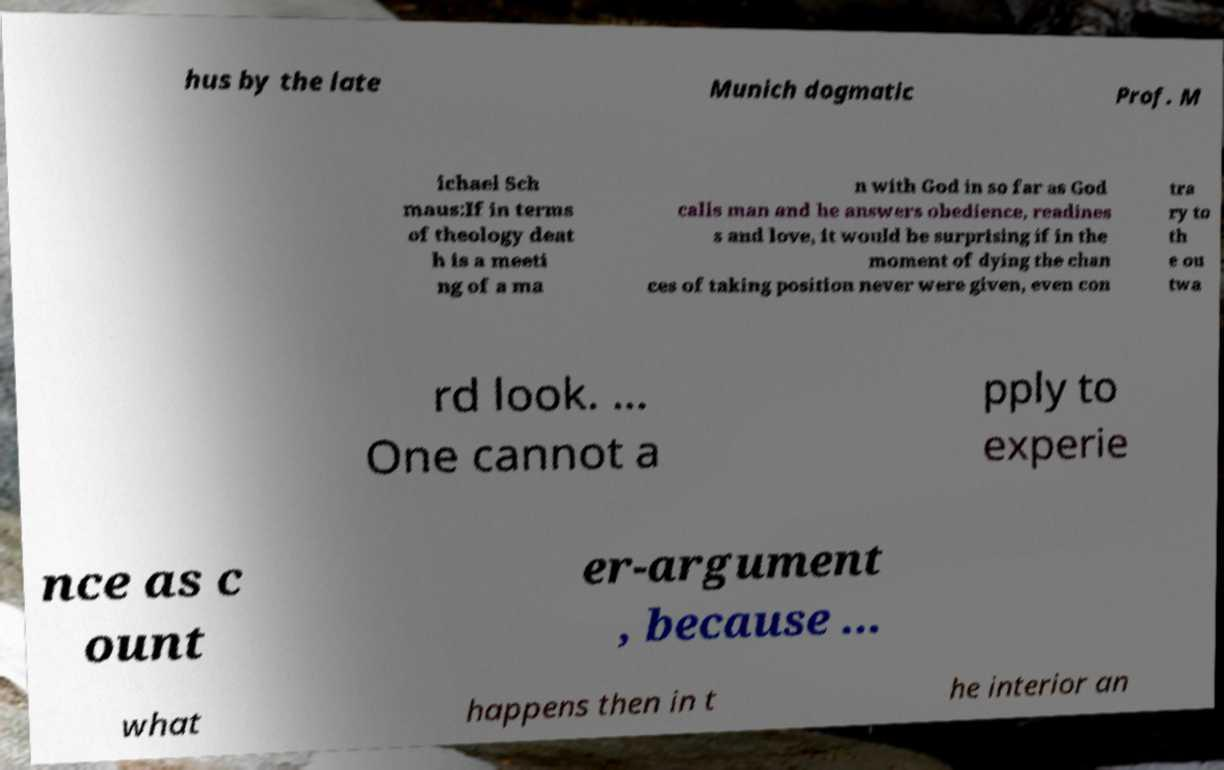There's text embedded in this image that I need extracted. Can you transcribe it verbatim? hus by the late Munich dogmatic Prof. M ichael Sch maus:If in terms of theology deat h is a meeti ng of a ma n with God in so far as God calls man and he answers obedience, readines s and love, it would be surprising if in the moment of dying the chan ces of taking position never were given, even con tra ry to th e ou twa rd look. ... One cannot a pply to experie nce as c ount er-argument , because ... what happens then in t he interior an 